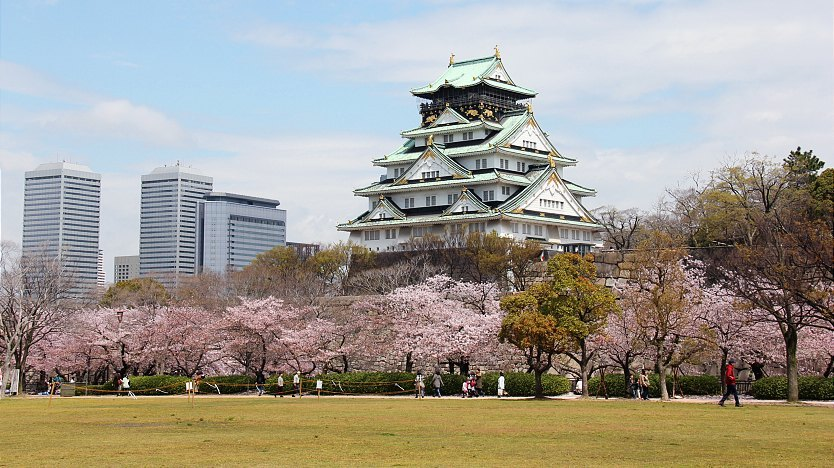If you could teleport to gain a bird's-eye view over Osaka Castle and its surroundings, what would you see? A bird's-eye view over Osaka Castle would reveal a stunning mosaic of natural and urban landscapes. The castle, with its elegant tiers and green roofs, would stand at the center, surrounded by the lush green expanse of Osaka Castle Park. Pink cherry blossoms would weave their way through the park, creating rivers of color that contrast beautifully with the castle's architecture. Beyond the park, the sprawling cityscape of Osaka would stretch out, skyscrapers reaching towards the sky, and busy streets teeming with life. You'd see the convergence of past and present, tradition and modernity, all encapsulated in one breathtaking panorama that epitomizes the dynamic spirit of Osaka. 